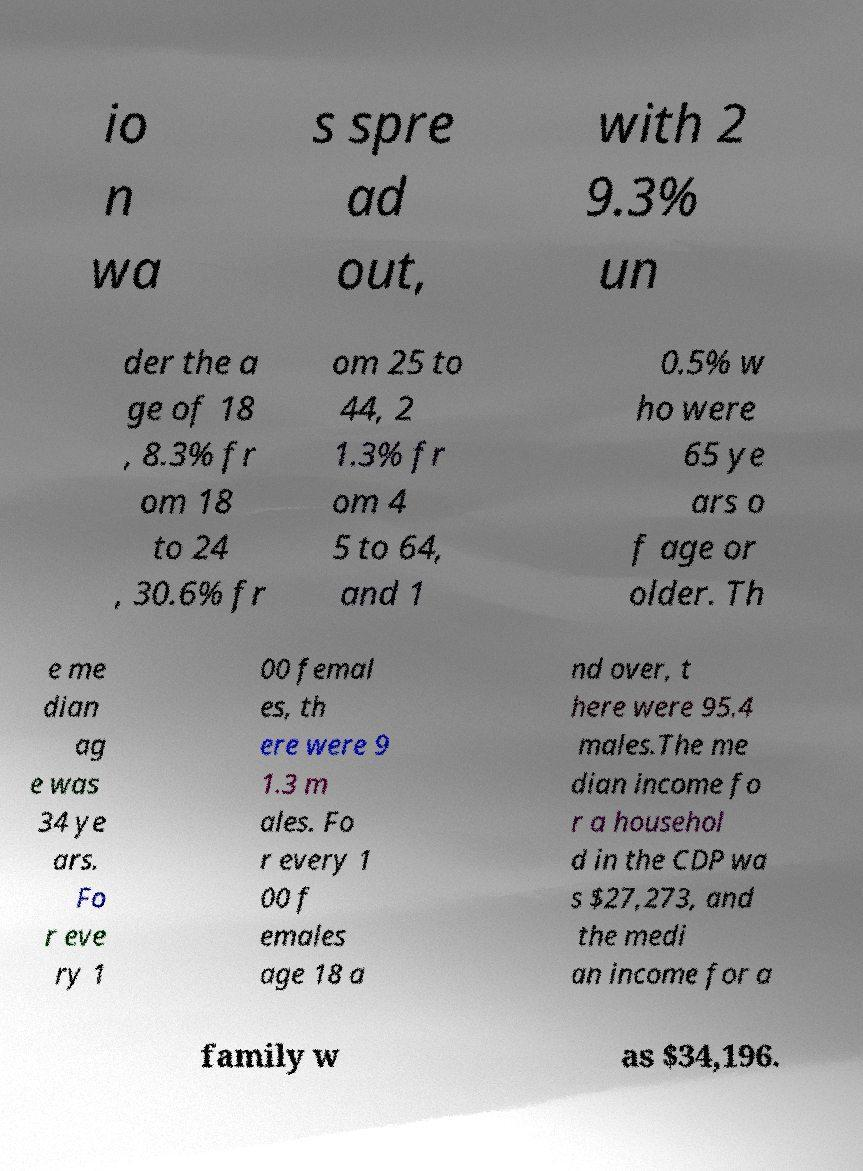Please identify and transcribe the text found in this image. io n wa s spre ad out, with 2 9.3% un der the a ge of 18 , 8.3% fr om 18 to 24 , 30.6% fr om 25 to 44, 2 1.3% fr om 4 5 to 64, and 1 0.5% w ho were 65 ye ars o f age or older. Th e me dian ag e was 34 ye ars. Fo r eve ry 1 00 femal es, th ere were 9 1.3 m ales. Fo r every 1 00 f emales age 18 a nd over, t here were 95.4 males.The me dian income fo r a househol d in the CDP wa s $27,273, and the medi an income for a family w as $34,196. 